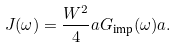Convert formula to latex. <formula><loc_0><loc_0><loc_500><loc_500>J ( \omega ) = \frac { W ^ { 2 } } 4 a G _ { \text {imp} } ( \omega ) a .</formula> 